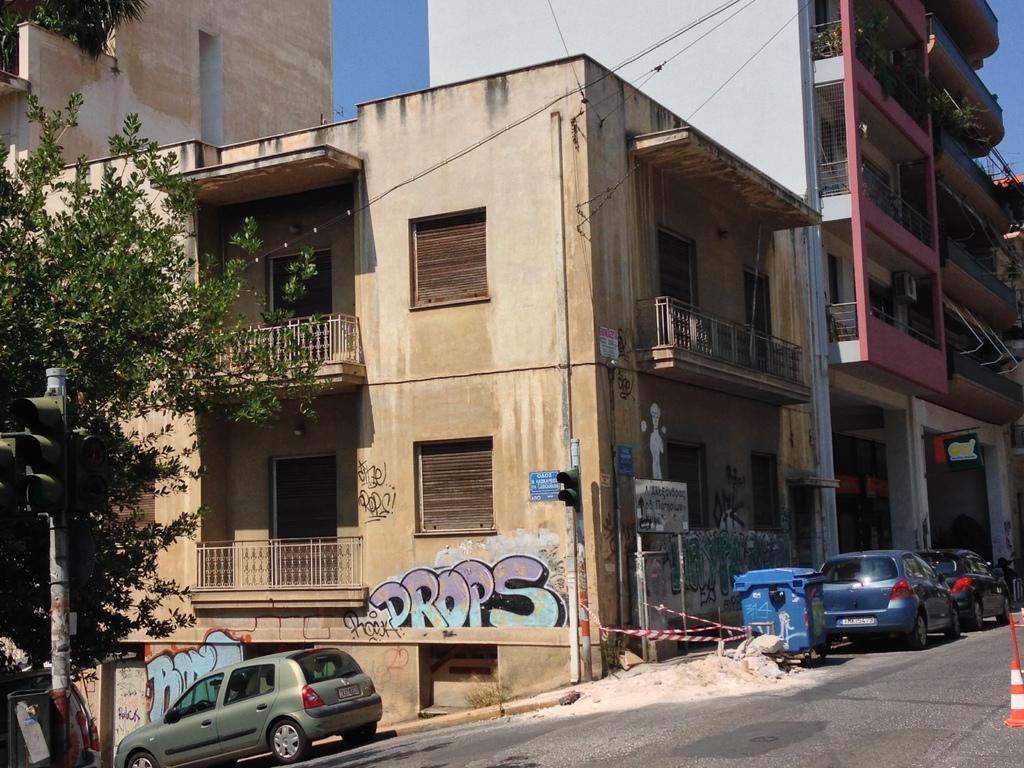Could you give a brief overview of what you see in this image? In this picture there is a small brown color house with balcony. Beside there are some cars parked in the lane. Behind there is a pink color building. On the left bottom side there is a golden color car parked in the lane and a tree. 